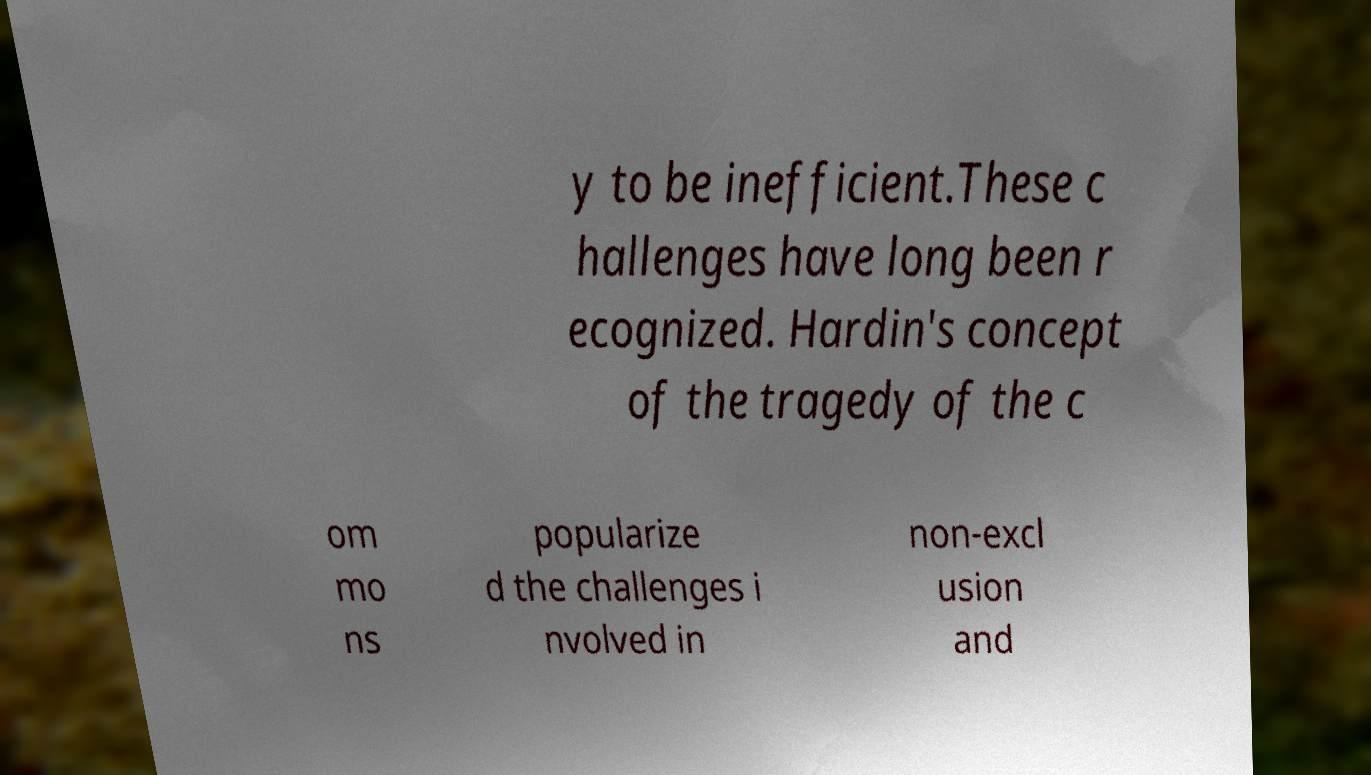Can you accurately transcribe the text from the provided image for me? y to be inefficient.These c hallenges have long been r ecognized. Hardin's concept of the tragedy of the c om mo ns popularize d the challenges i nvolved in non-excl usion and 